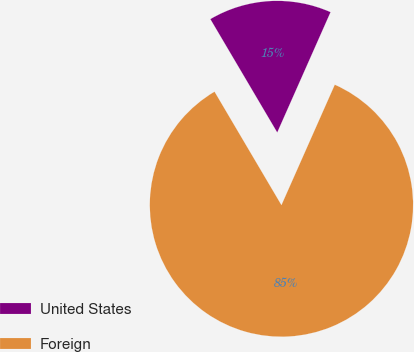Convert chart to OTSL. <chart><loc_0><loc_0><loc_500><loc_500><pie_chart><fcel>United States<fcel>Foreign<nl><fcel>15.12%<fcel>84.88%<nl></chart> 